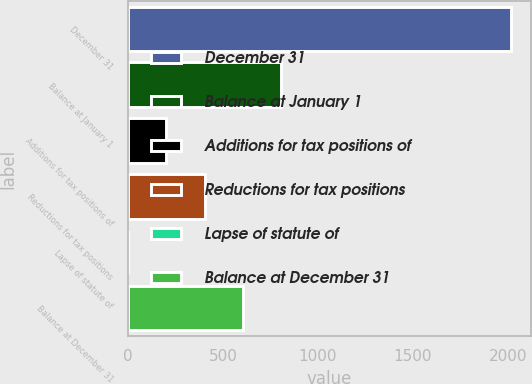Convert chart to OTSL. <chart><loc_0><loc_0><loc_500><loc_500><bar_chart><fcel>December 31<fcel>Balance at January 1<fcel>Additions for tax positions of<fcel>Reductions for tax positions<fcel>Lapse of statute of<fcel>Balance at December 31<nl><fcel>2017<fcel>807.4<fcel>202.6<fcel>404.2<fcel>1<fcel>605.8<nl></chart> 